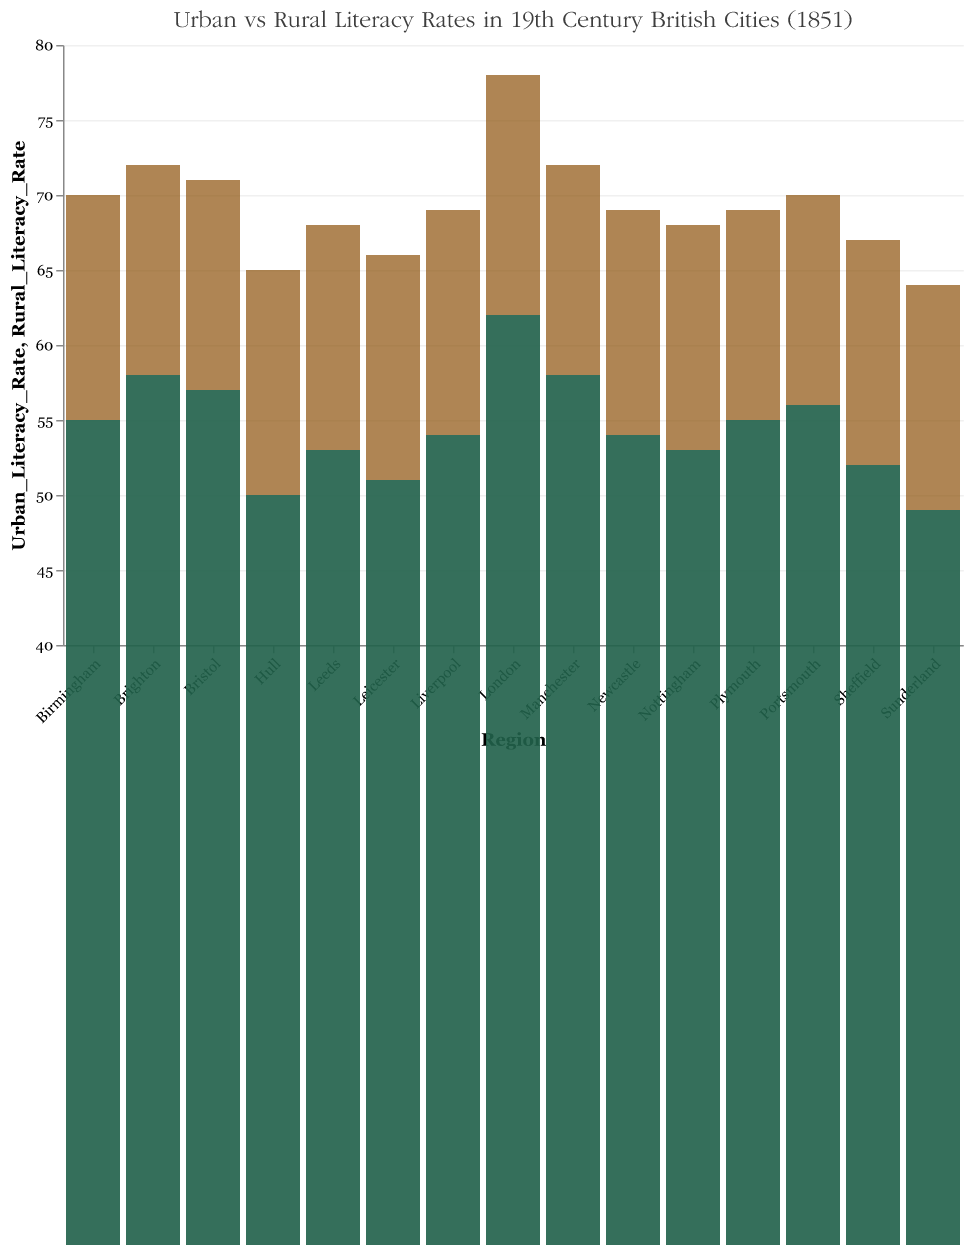What is the title of the figure? The title is usually displayed prominently at the top of the figure. It typically summarizes the main content or the key point of the plot.
Answer: Urban vs Rural Literacy Rates in 19th Century British Cities (1851) What is the color used for the urban literacy rate bars? By visually inspecting the bars that represent urban literacy rates, you can identify which color is consistently used for them.
Answer: #8c510a What is the lowest urban literacy rate displayed in the figure? Look at the heights of the bars representing urban literacy rates and identify the smallest value.
Answer: 64 Which region has the highest rural literacy rate? Compare the heights of the bars for rural literacy rates and identify the tallest one.
Answer: London What is the difference between urban and rural literacy rates in Liverpool? Locate the urban and rural literacy rates for Liverpool and then subtract the rural rate from the urban rate. 69 (Urban) - 54 (Rural) gives the difference.
Answer: 15 What is the average urban literacy rate for all regions displayed? To get the average, sum all urban literacy rates and then divide by the number of regions (15). Sum: 78 + 72 + 70 + 69 + 68 + 67 + 71 + 69 + 70 + 66 + 68 + 65 + 69 + 64 + 72 = 1098, Divide by 15: 1098/15 = 73.2.
Answer: 73.2 Which regions have urban literacy rates above 70? Identify regions where the bar representing urban literacy rates crosses the 70% line.
Answer: London, Manchester, Birmingham, Bristol, Portsmouth, Brighton How does the rural literacy rate in Sunderland compare to that in Hull? Compare the heights of the rural literacy rate bars for Sunderland and Hull.
Answer: Sunderland's rural rate is slightly higher (49 vs. 50) What is the median rural literacy rate across all regions? List all rural literacy rates in ascending order and find the middle value. Ordered: 49, 50, 51, 52, 53, 53, 54, 54, 55, 55, 56, 57, 58, 58, 62, The middle value (8th item) of these 15 values is 54.
Answer: 54 What are the literacy rates for Sheffield? Look at the bars designated for Sheffield and note both the urban and rural literacy rates.
Answer: Urban: 67, Rural: 52 